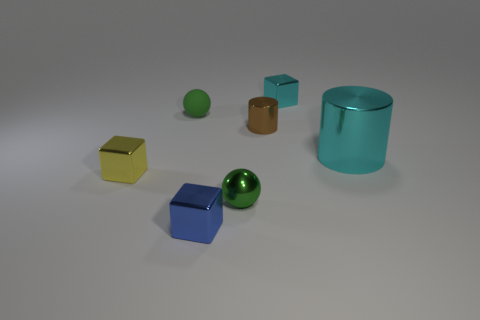What color is the tiny metallic cylinder?
Provide a short and direct response. Brown. Is the number of cyan cylinders in front of the tiny yellow metal thing less than the number of purple objects?
Make the answer very short. No. Are there any other things that are the same shape as the yellow shiny object?
Make the answer very short. Yes. Are there any rubber things?
Your answer should be compact. Yes. Are there fewer brown cylinders than yellow matte objects?
Ensure brevity in your answer.  No. What number of other small things are the same material as the small yellow thing?
Provide a succinct answer. 4. The cylinder that is made of the same material as the big object is what color?
Make the answer very short. Brown. The tiny blue metal thing has what shape?
Your response must be concise. Cube. What number of other big metal cylinders have the same color as the large cylinder?
Ensure brevity in your answer.  0. There is a yellow metallic object that is the same size as the blue object; what is its shape?
Offer a terse response. Cube. 